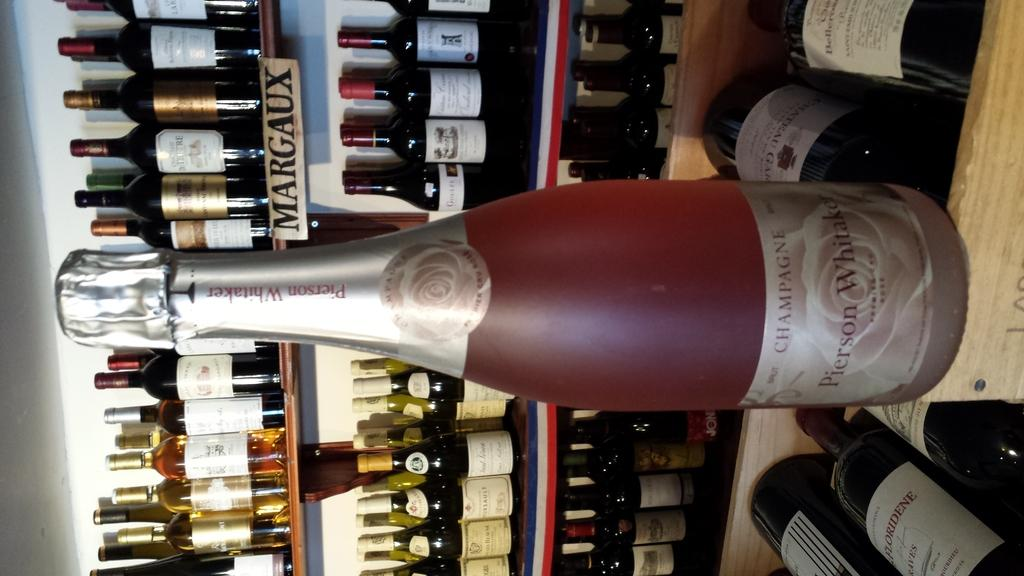<image>
Share a concise interpretation of the image provided. A collection of wines with a bottle of red Pierson Whitaker at the front. 